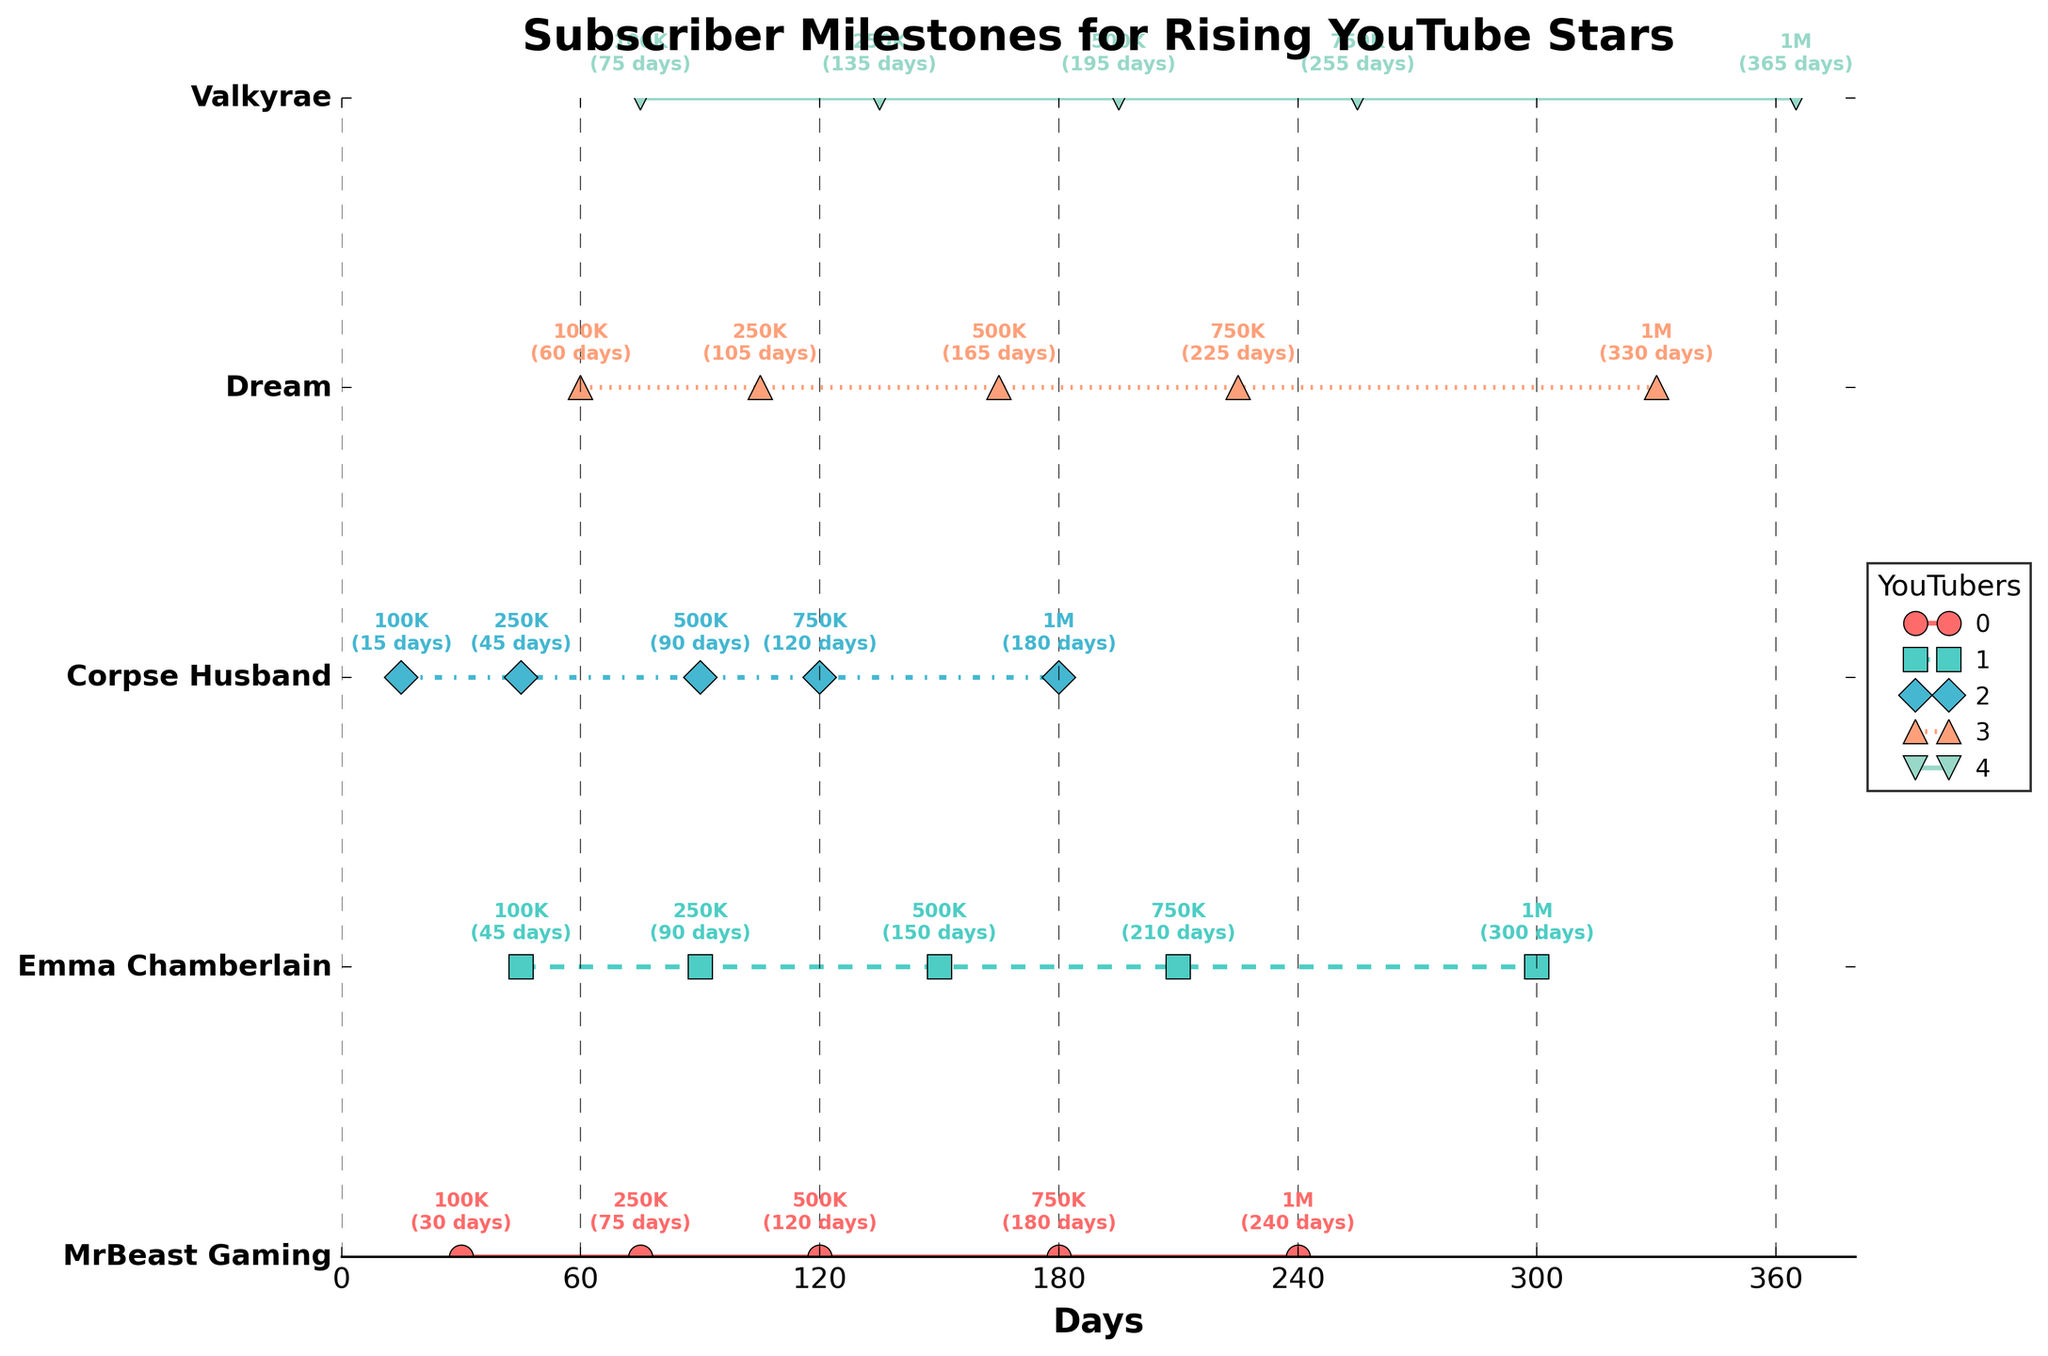What's the title of the figure? The title is usually displayed at the top of the plot. It provides a summary of what the plot represents. In this case, it is "Subscriber Milestones for Rising YouTube Stars".
Answer: Subscriber Milestones for Rising YouTube Stars Which YouTuber reached 100K subscribers the fastest? To find the YouTuber who reached 100K subscribers the fastest, we look for the YouTube star with the smallest value in the 100K milestone column. Corpse Husband reached 100K in just 15 days.
Answer: Corpse Husband How many days did Emma Chamberlain take to reach 1 million subscribers? We need to look at the data point corresponding to the 1M milestone for Emma Chamberlain. It's annotated on the plot, and it shows that she took 300 days.
Answer: 300 What is the range of days taken by MrBeast Gaming to reach from 100K to 1 million subscribers? The range is calculated by subtracting the days taken to reach 100K from the days taken to reach 1 million. MrBeast Gaming took 240 days to reach 1 million and 30 days to reach 100K, so the range is 240 - 30 = 210 days.
Answer: 210 days Compare the time Dream and Valkyrae took to reach 750K subscribers. Who took longer? We need to look at the annotations for the 750K milestone for both Dream and Valkyrae. Dream took 225 days while Valkyrae took 255 days. Valkyrae took longer.
Answer: Valkyrae Which YouTuber reached all milestones the fastest, on average? We need to calculate the average days taken for each milestone by adding all milestone days and dividing by the number of milestones. Corpse Husband: (15+45+90+120+180)/5 = 90 days; MrBeast Gaming: (30+75+120+180+240)/5 = 129 days; Emma Chamberlain: (45+90+150+210+300)/5 = 159 days; Dream: (60+105+165+225+330)/5 = 177 days; Valkyrae: (75+135+195+255+365)/5 = 205 days. Corpse Husband has the lowest average.
Answer: Corpse Husband Identify the milestone where Dream and MrBeast Gaming reached the same subscriber count in the shortest amount of time. We look for the milestone where their days are closest or the same. Both reached 250K (Dream in 105 days and MrBeast Gaming in 75 days), but MrBeast Gaming’s milestone is earlier, so it is the 250K milestone.
Answer: 250K What is the maximum number of days any YouTuber took to reach 1 million subscribers from the list? We identify the largest number in the 1M column. Valkyrae took 365 days, the maximum time taken in the dataset.
Answer: 365 days 